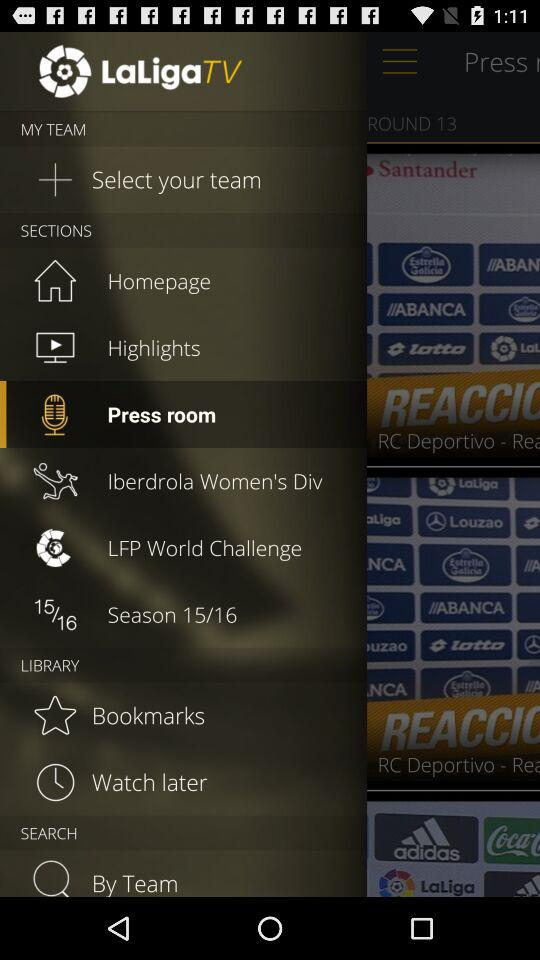What is the name of the application? The name of the application is "LaLigaTV". 